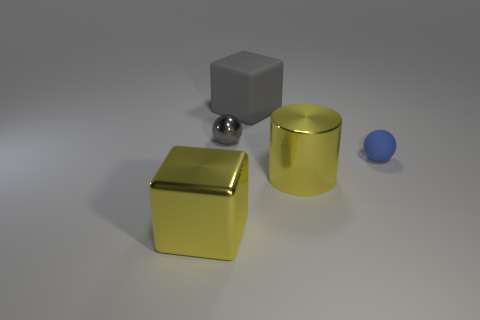Add 4 gray spheres. How many objects exist? 9 Subtract all cylinders. How many objects are left? 4 Add 3 small metal things. How many small metal things are left? 4 Add 2 gray things. How many gray things exist? 4 Subtract 0 red balls. How many objects are left? 5 Subtract all small matte objects. Subtract all tiny blue rubber things. How many objects are left? 3 